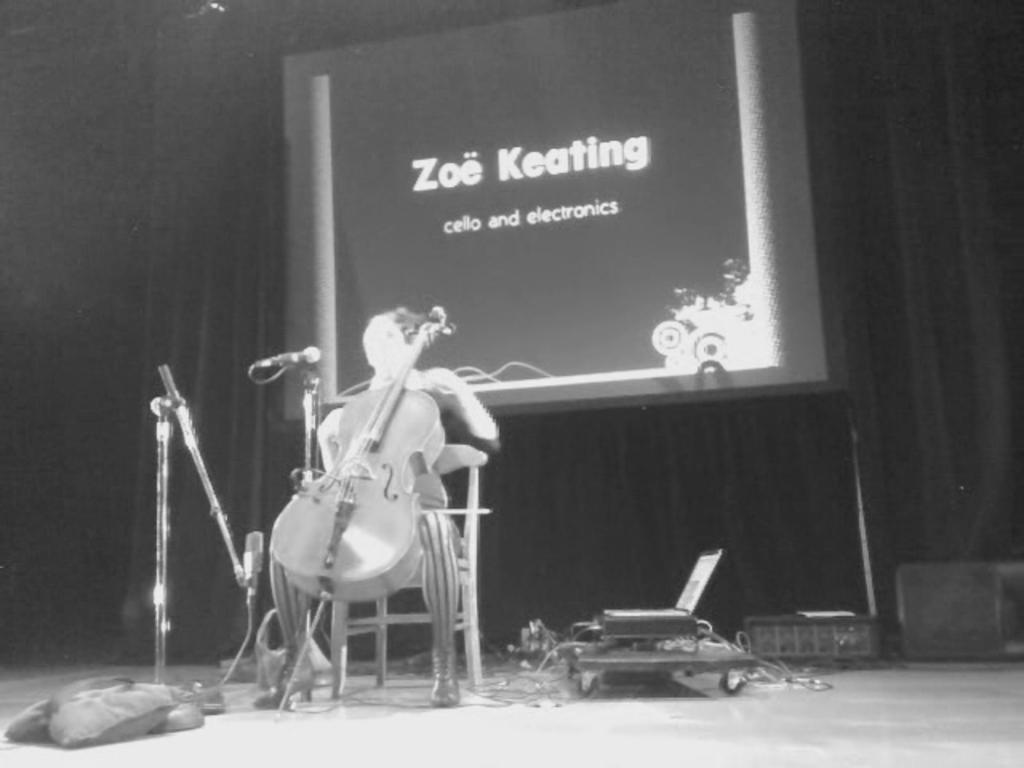Please provide a concise description of this image. In this image I can see an old photograph in which I can see a person is sitting on a chair and holding a musical instrument. I can see few microphones, the curtain and a board. 